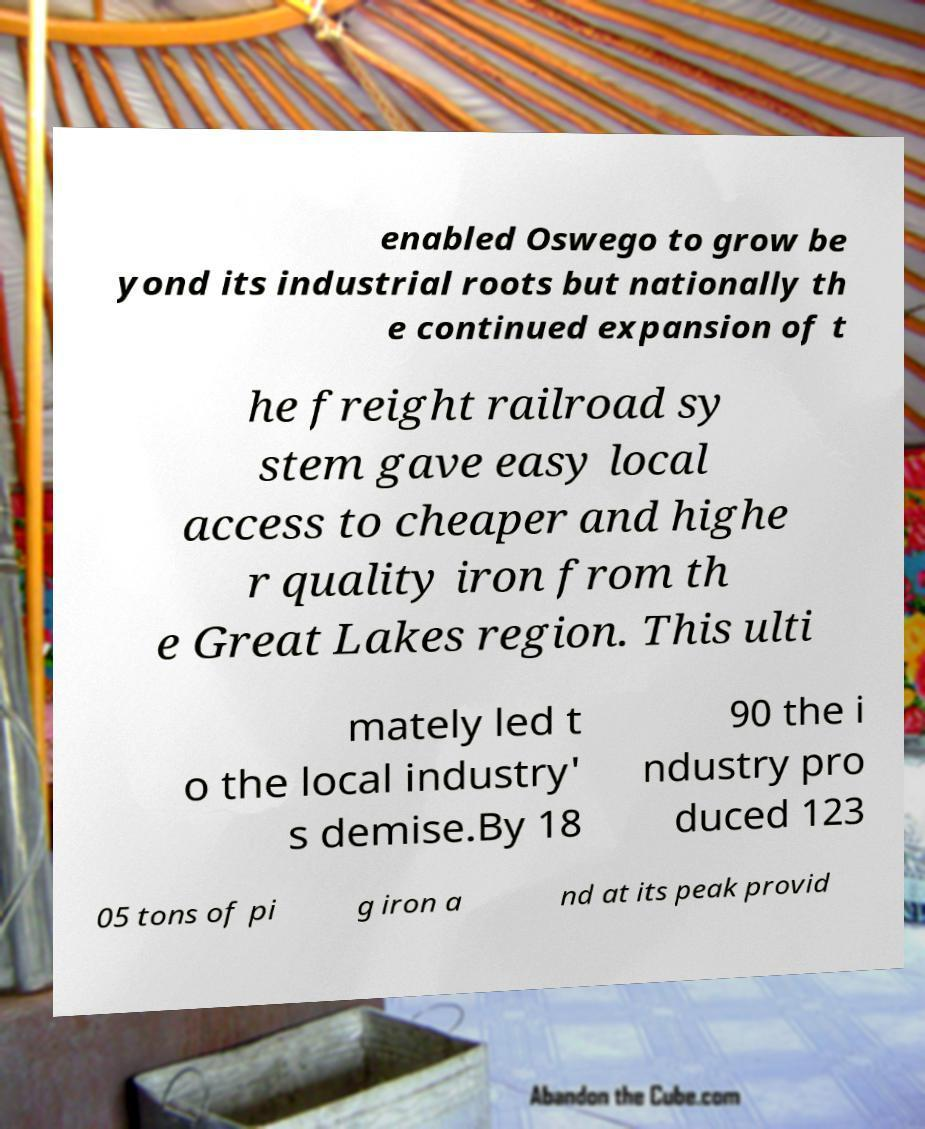Can you read and provide the text displayed in the image?This photo seems to have some interesting text. Can you extract and type it out for me? enabled Oswego to grow be yond its industrial roots but nationally th e continued expansion of t he freight railroad sy stem gave easy local access to cheaper and highe r quality iron from th e Great Lakes region. This ulti mately led t o the local industry' s demise.By 18 90 the i ndustry pro duced 123 05 tons of pi g iron a nd at its peak provid 